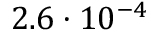<formula> <loc_0><loc_0><loc_500><loc_500>2 . 6 \cdot 1 0 ^ { - 4 }</formula> 